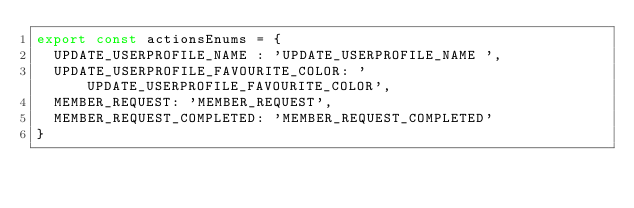Convert code to text. <code><loc_0><loc_0><loc_500><loc_500><_TypeScript_>export const actionsEnums = {
  UPDATE_USERPROFILE_NAME : 'UPDATE_USERPROFILE_NAME ',
  UPDATE_USERPROFILE_FAVOURITE_COLOR: 'UPDATE_USERPROFILE_FAVOURITE_COLOR',
  MEMBER_REQUEST: 'MEMBER_REQUEST',
  MEMBER_REQUEST_COMPLETED: 'MEMBER_REQUEST_COMPLETED'
}
</code> 